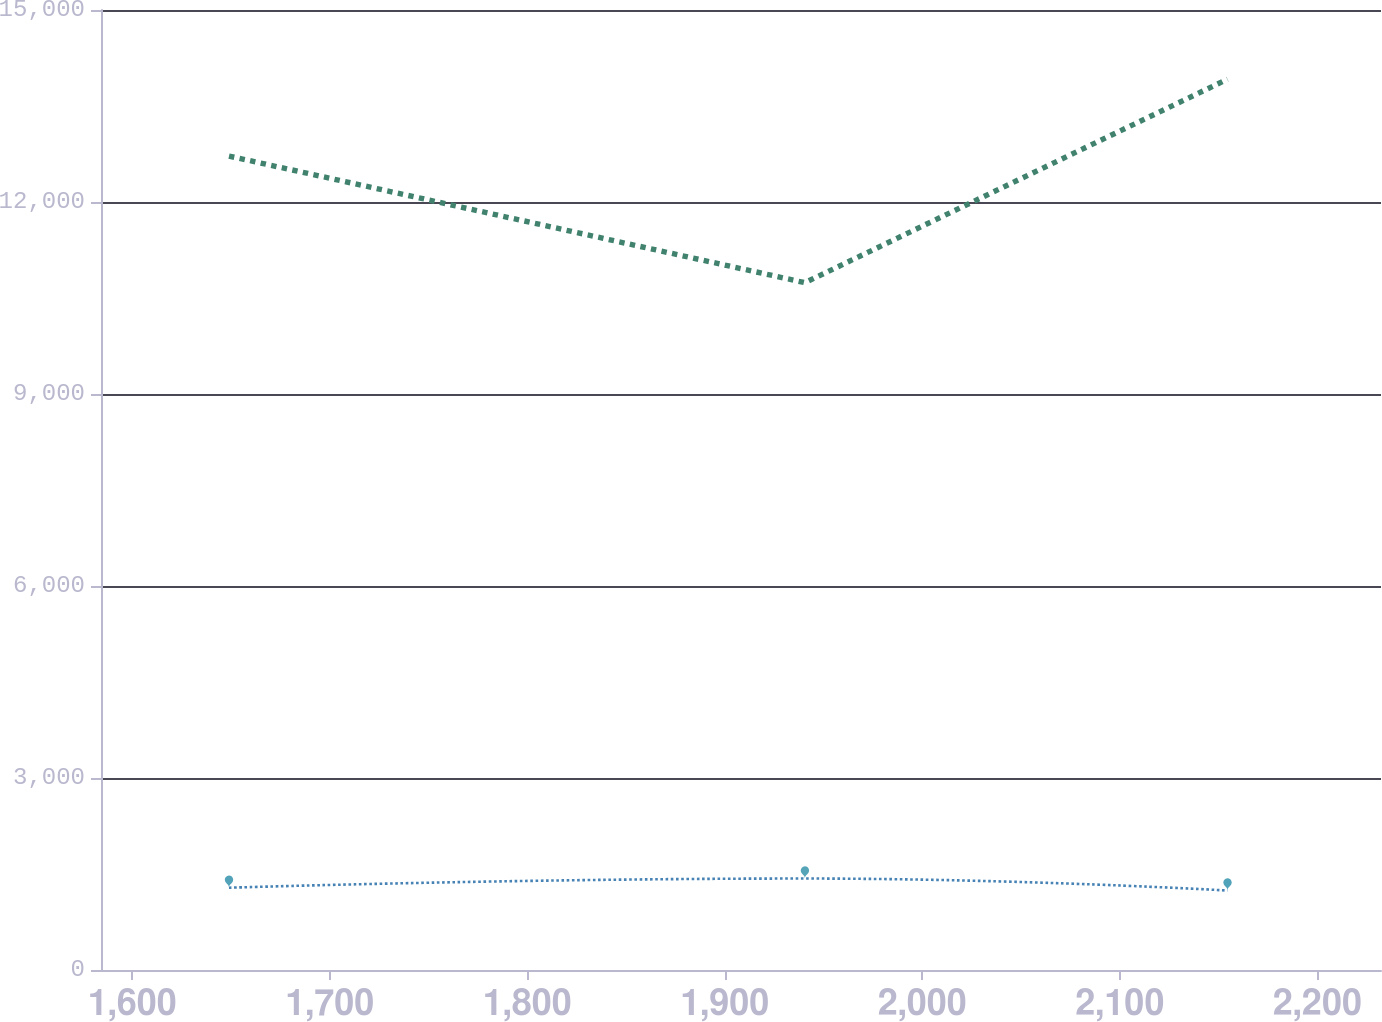<chart> <loc_0><loc_0><loc_500><loc_500><line_chart><ecel><fcel>Capital leases<fcel>Non-cancellable Operating leases<nl><fcel>1648.95<fcel>1285.59<fcel>12717.4<nl><fcel>1940.54<fcel>1429.09<fcel>10739.8<nl><fcel>2154.51<fcel>1241.79<fcel>13918.8<nl><fcel>2236.29<fcel>1197.99<fcel>12418.7<nl><fcel>2297.02<fcel>1635.95<fcel>13620.1<nl></chart> 